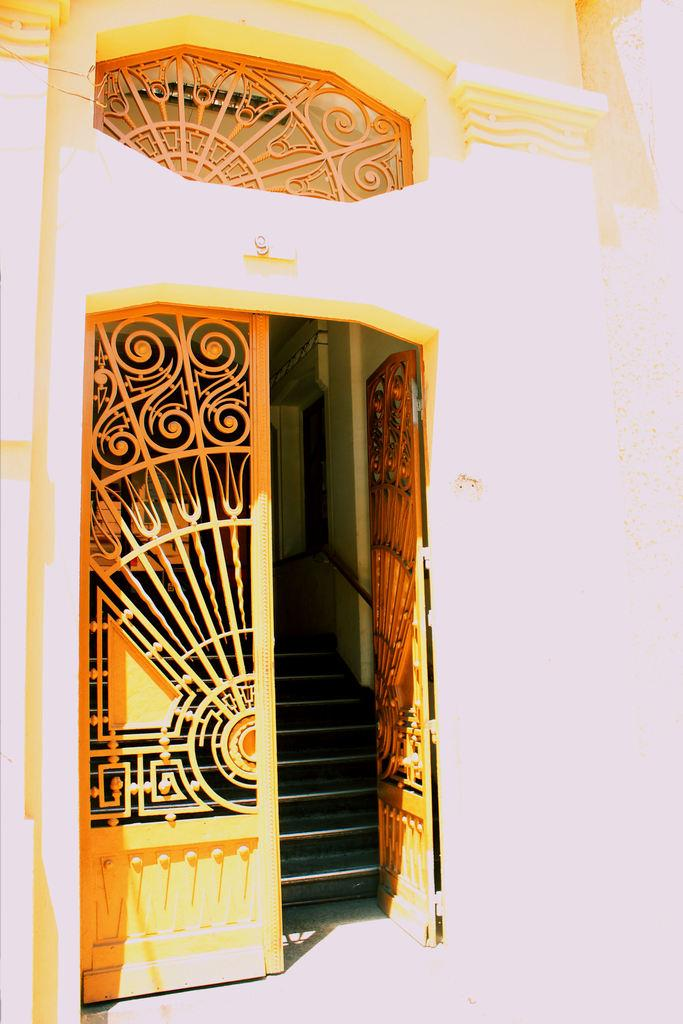What is the main feature of the image? The main feature of the image is an open door. What type of structure does the open door belong to? The open door belongs to a building. Are there any architectural features visible in the image? Yes, there are stairs visible in the image. What type of dogs can be seen playing in the band in the image? There are no dogs or bands present in the image; it only features an open door and stairs. 